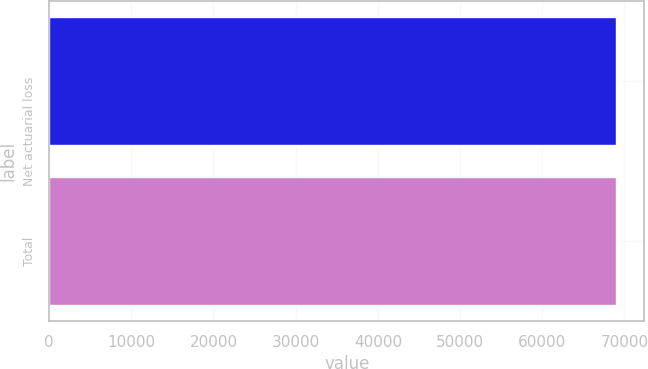<chart> <loc_0><loc_0><loc_500><loc_500><bar_chart><fcel>Net actuarial loss<fcel>Total<nl><fcel>68970<fcel>68970.1<nl></chart> 